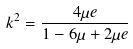Convert formula to latex. <formula><loc_0><loc_0><loc_500><loc_500>k ^ { 2 } = \frac { 4 \mu e } { 1 - 6 \mu + 2 \mu e }</formula> 